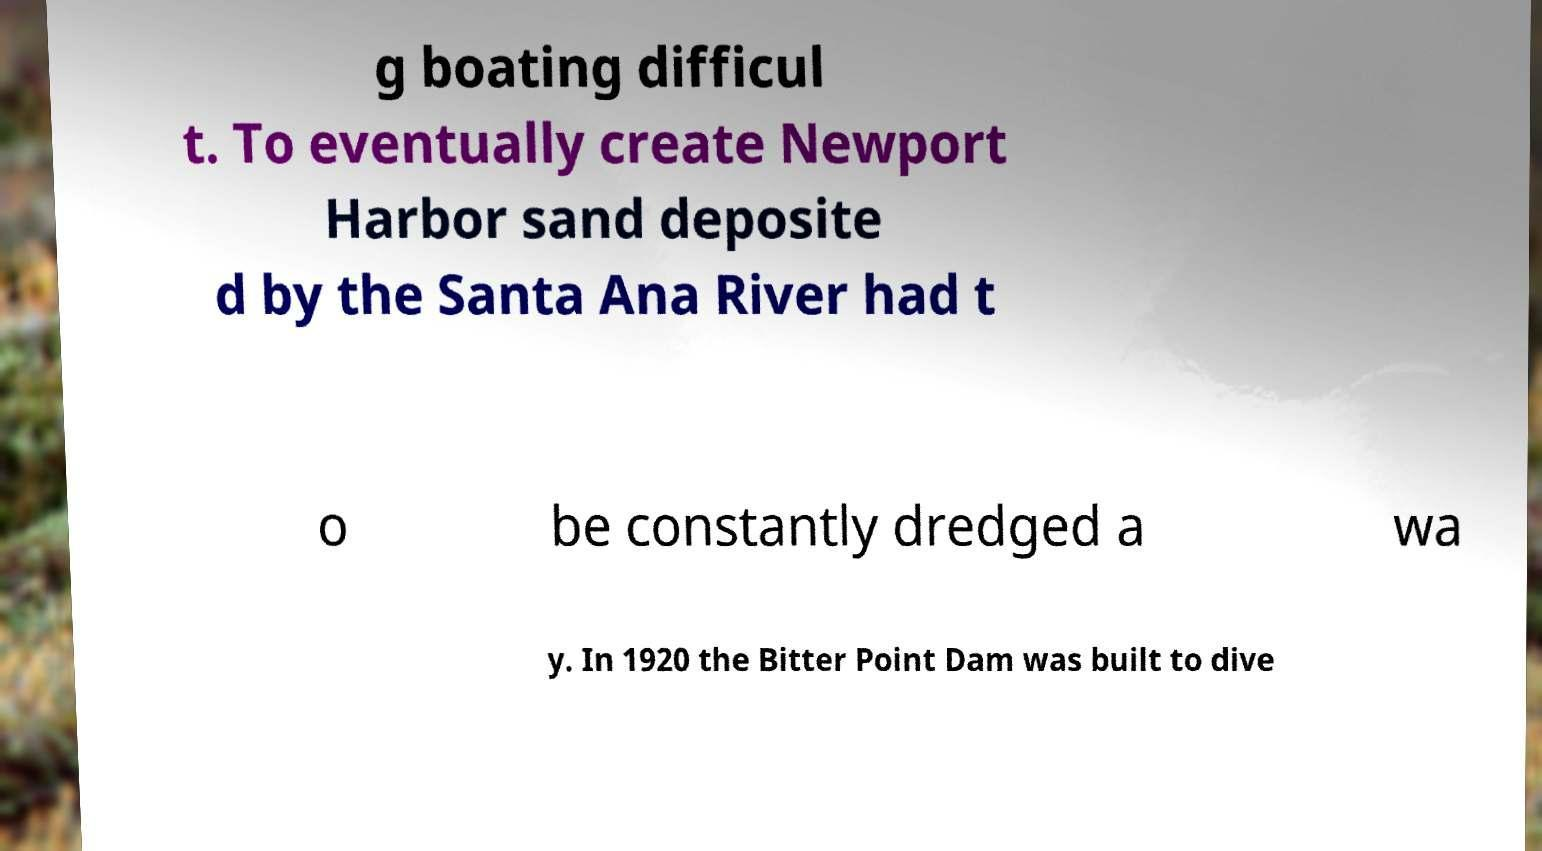Can you read and provide the text displayed in the image?This photo seems to have some interesting text. Can you extract and type it out for me? g boating difficul t. To eventually create Newport Harbor sand deposite d by the Santa Ana River had t o be constantly dredged a wa y. In 1920 the Bitter Point Dam was built to dive 